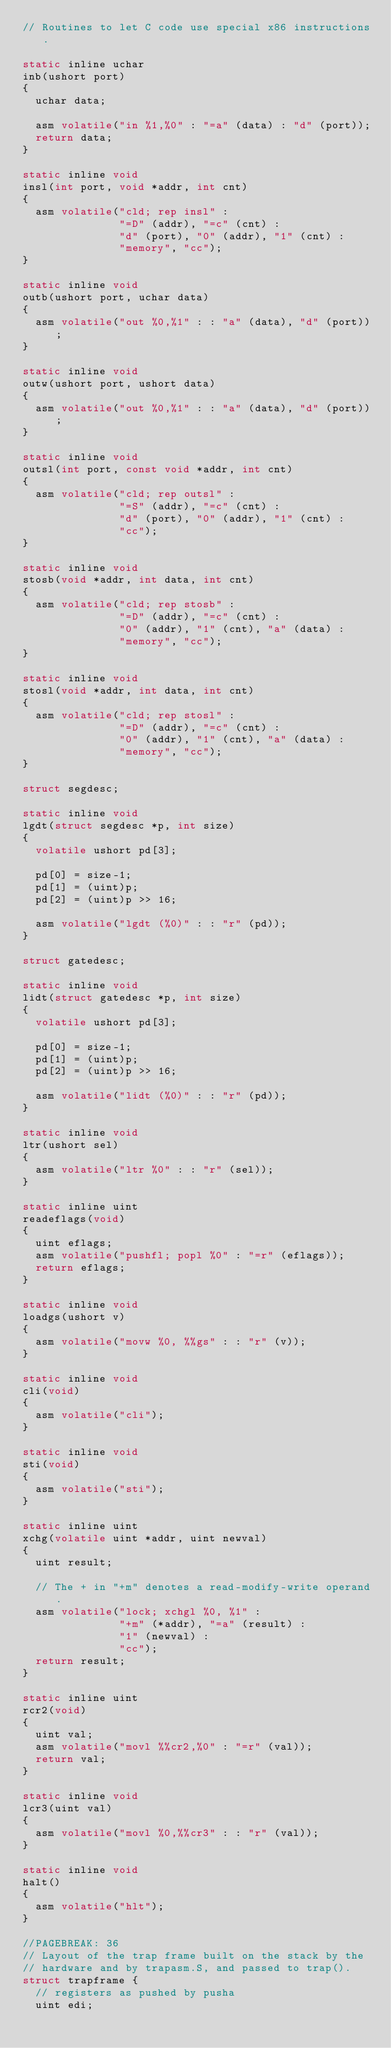<code> <loc_0><loc_0><loc_500><loc_500><_C_>// Routines to let C code use special x86 instructions.

static inline uchar
inb(ushort port)
{
  uchar data;

  asm volatile("in %1,%0" : "=a" (data) : "d" (port));
  return data;
}

static inline void
insl(int port, void *addr, int cnt)
{
  asm volatile("cld; rep insl" :
               "=D" (addr), "=c" (cnt) :
               "d" (port), "0" (addr), "1" (cnt) :
               "memory", "cc");
}

static inline void
outb(ushort port, uchar data)
{
  asm volatile("out %0,%1" : : "a" (data), "d" (port));
}

static inline void
outw(ushort port, ushort data)
{
  asm volatile("out %0,%1" : : "a" (data), "d" (port));
}

static inline void
outsl(int port, const void *addr, int cnt)
{
  asm volatile("cld; rep outsl" :
               "=S" (addr), "=c" (cnt) :
               "d" (port), "0" (addr), "1" (cnt) :
               "cc");
}

static inline void
stosb(void *addr, int data, int cnt)
{
  asm volatile("cld; rep stosb" :
               "=D" (addr), "=c" (cnt) :
               "0" (addr), "1" (cnt), "a" (data) :
               "memory", "cc");
}

static inline void
stosl(void *addr, int data, int cnt)
{
  asm volatile("cld; rep stosl" :
               "=D" (addr), "=c" (cnt) :
               "0" (addr), "1" (cnt), "a" (data) :
               "memory", "cc");
}

struct segdesc;

static inline void
lgdt(struct segdesc *p, int size)
{
  volatile ushort pd[3];

  pd[0] = size-1;
  pd[1] = (uint)p;
  pd[2] = (uint)p >> 16;

  asm volatile("lgdt (%0)" : : "r" (pd));
}

struct gatedesc;

static inline void
lidt(struct gatedesc *p, int size)
{
  volatile ushort pd[3];

  pd[0] = size-1;
  pd[1] = (uint)p;
  pd[2] = (uint)p >> 16;

  asm volatile("lidt (%0)" : : "r" (pd));
}

static inline void
ltr(ushort sel)
{
  asm volatile("ltr %0" : : "r" (sel));
}

static inline uint
readeflags(void)
{
  uint eflags;
  asm volatile("pushfl; popl %0" : "=r" (eflags));
  return eflags;
}

static inline void
loadgs(ushort v)
{
  asm volatile("movw %0, %%gs" : : "r" (v));
}

static inline void
cli(void)
{
  asm volatile("cli");
}

static inline void
sti(void)
{
  asm volatile("sti");
}

static inline uint
xchg(volatile uint *addr, uint newval)
{
  uint result;

  // The + in "+m" denotes a read-modify-write operand.
  asm volatile("lock; xchgl %0, %1" :
               "+m" (*addr), "=a" (result) :
               "1" (newval) :
               "cc");
  return result;
}

static inline uint
rcr2(void)
{
  uint val;
  asm volatile("movl %%cr2,%0" : "=r" (val));
  return val;
}

static inline void
lcr3(uint val)
{
  asm volatile("movl %0,%%cr3" : : "r" (val));
}

static inline void
halt()
{
  asm volatile("hlt");
}

//PAGEBREAK: 36
// Layout of the trap frame built on the stack by the
// hardware and by trapasm.S, and passed to trap().
struct trapframe {
  // registers as pushed by pusha
  uint edi;</code> 